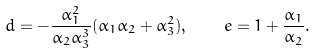Convert formula to latex. <formula><loc_0><loc_0><loc_500><loc_500>d = - \frac { \alpha _ { 1 } ^ { 2 } } { \alpha _ { 2 } \alpha _ { 3 } ^ { 3 } } ( \alpha _ { 1 } \alpha _ { 2 } + \alpha _ { 3 } ^ { 2 } ) , \quad e = 1 + \frac { \alpha _ { 1 } } { \alpha _ { 2 } } .</formula> 